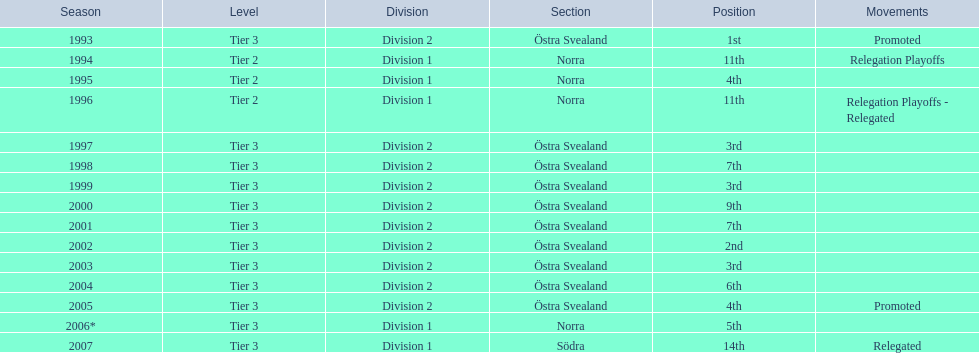What year is the lowest on the list? 2007. 